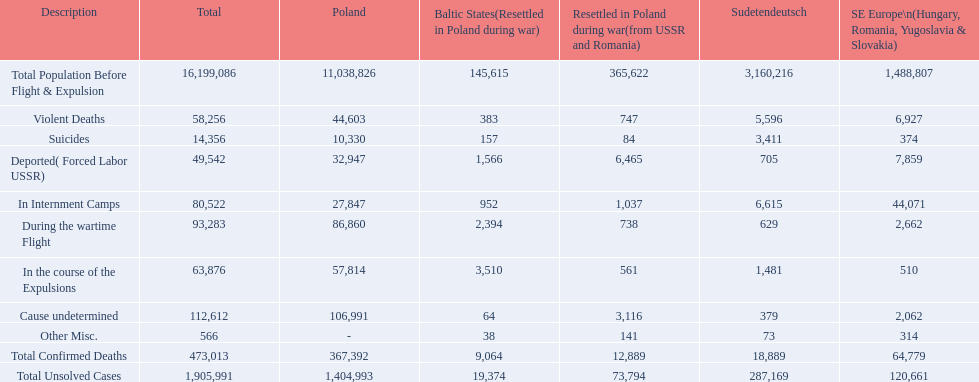What were the total number of confirmed deaths? 473,013. Of these, how many were violent? 58,256. What is the total of deaths in each group for the baltic countries? 145,615, 383, 157, 1,566, 952, 2,394, 3,510, 64, 38, 9,064, 19,374. How many deaths with unclear causes were present in the baltic countries? 64. How many other assorted deaths occurred in the baltic countries? 38. Could you parse the entire table? {'header': ['Description', 'Total', 'Poland', 'Baltic States(Resettled in Poland during war)', 'Resettled in Poland during war(from USSR and Romania)', 'Sudetendeutsch', 'SE Europe\\n(Hungary, Romania, Yugoslavia & Slovakia)'], 'rows': [['Total Population Before Flight & Expulsion', '16,199,086', '11,038,826', '145,615', '365,622', '3,160,216', '1,488,807'], ['Violent Deaths', '58,256', '44,603', '383', '747', '5,596', '6,927'], ['Suicides', '14,356', '10,330', '157', '84', '3,411', '374'], ['Deported( Forced Labor USSR)', '49,542', '32,947', '1,566', '6,465', '705', '7,859'], ['In Internment Camps', '80,522', '27,847', '952', '1,037', '6,615', '44,071'], ['During the wartime Flight', '93,283', '86,860', '2,394', '738', '629', '2,662'], ['In the course of the Expulsions', '63,876', '57,814', '3,510', '561', '1,481', '510'], ['Cause undetermined', '112,612', '106,991', '64', '3,116', '379', '2,062'], ['Other Misc.', '566', '-', '38', '141', '73', '314'], ['Total Confirmed Deaths', '473,013', '367,392', '9,064', '12,889', '18,889', '64,779'], ['Total Unsolved Cases', '1,905,991', '1,404,993', '19,374', '73,794', '287,169', '120,661']]} Which category has a greater number of deaths, unclear causes or miscellaneous? Cause undetermined. 